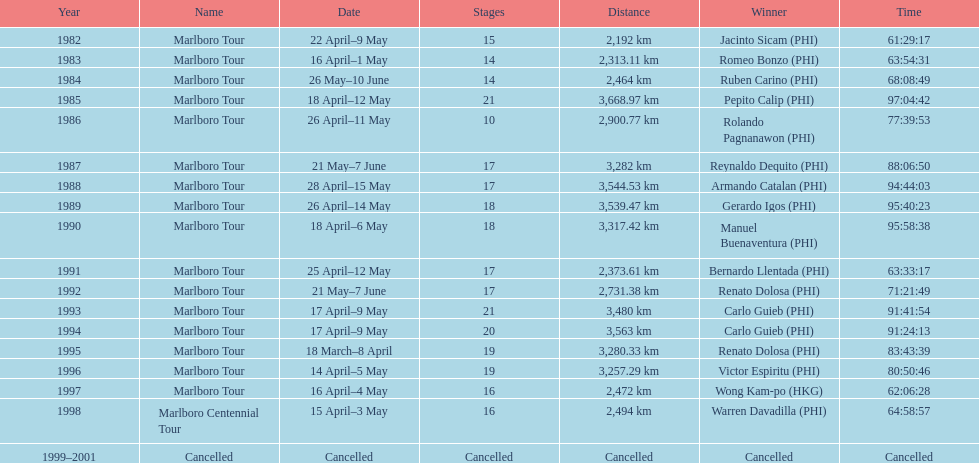How many stages was the 1982 marlboro tour? 15. 